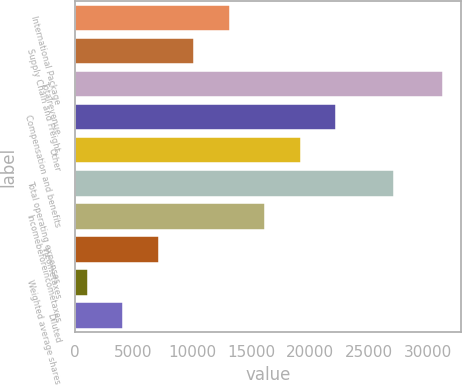Convert chart. <chart><loc_0><loc_0><loc_500><loc_500><bar_chart><fcel>International Package<fcel>Supply Chain and Freight<fcel>Totalrevenue<fcel>Compensation and benefits<fcel>Other<fcel>Total operating expenses<fcel>Incomebeforeincometaxes<fcel>Incometaxes<fcel>Weighted average shares<fcel>Diluted<nl><fcel>13180.8<fcel>10165.6<fcel>31272<fcel>22226.4<fcel>19211.2<fcel>27176<fcel>16196<fcel>7150.4<fcel>1120<fcel>4135.2<nl></chart> 